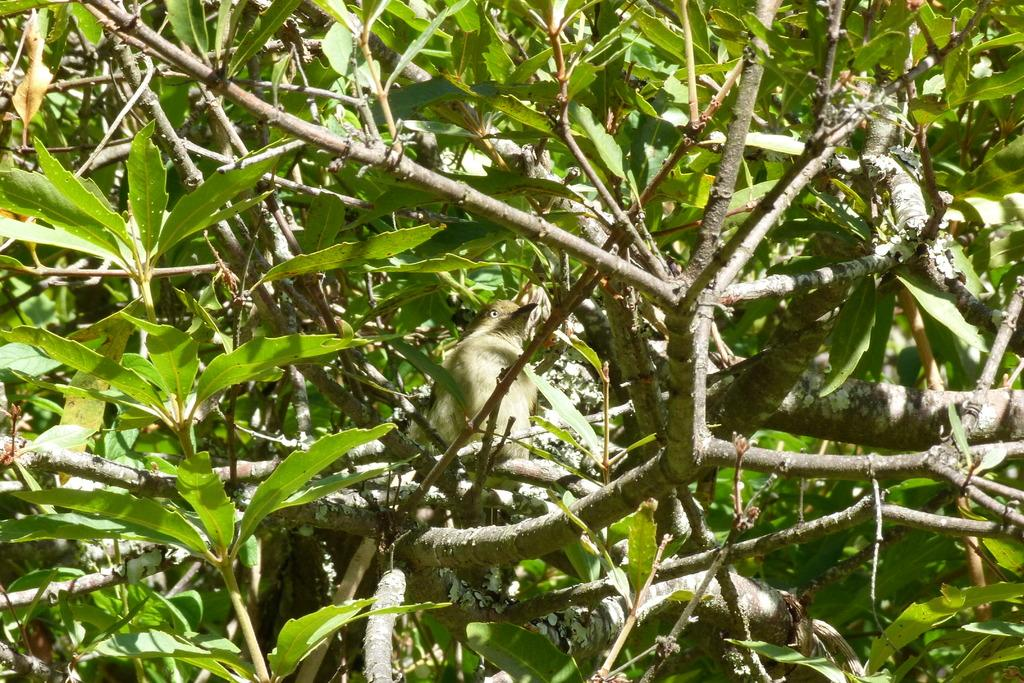What is present in the image that is not a part of the ground or sky? There is a tree in the image. Can you describe the tree in more detail? The tree has green leaves and a bird is sitting on a branch of the tree. What time of day is it in the image, based on the presence of a person? There is no person present in the image, so we cannot determine the hour based on that. 